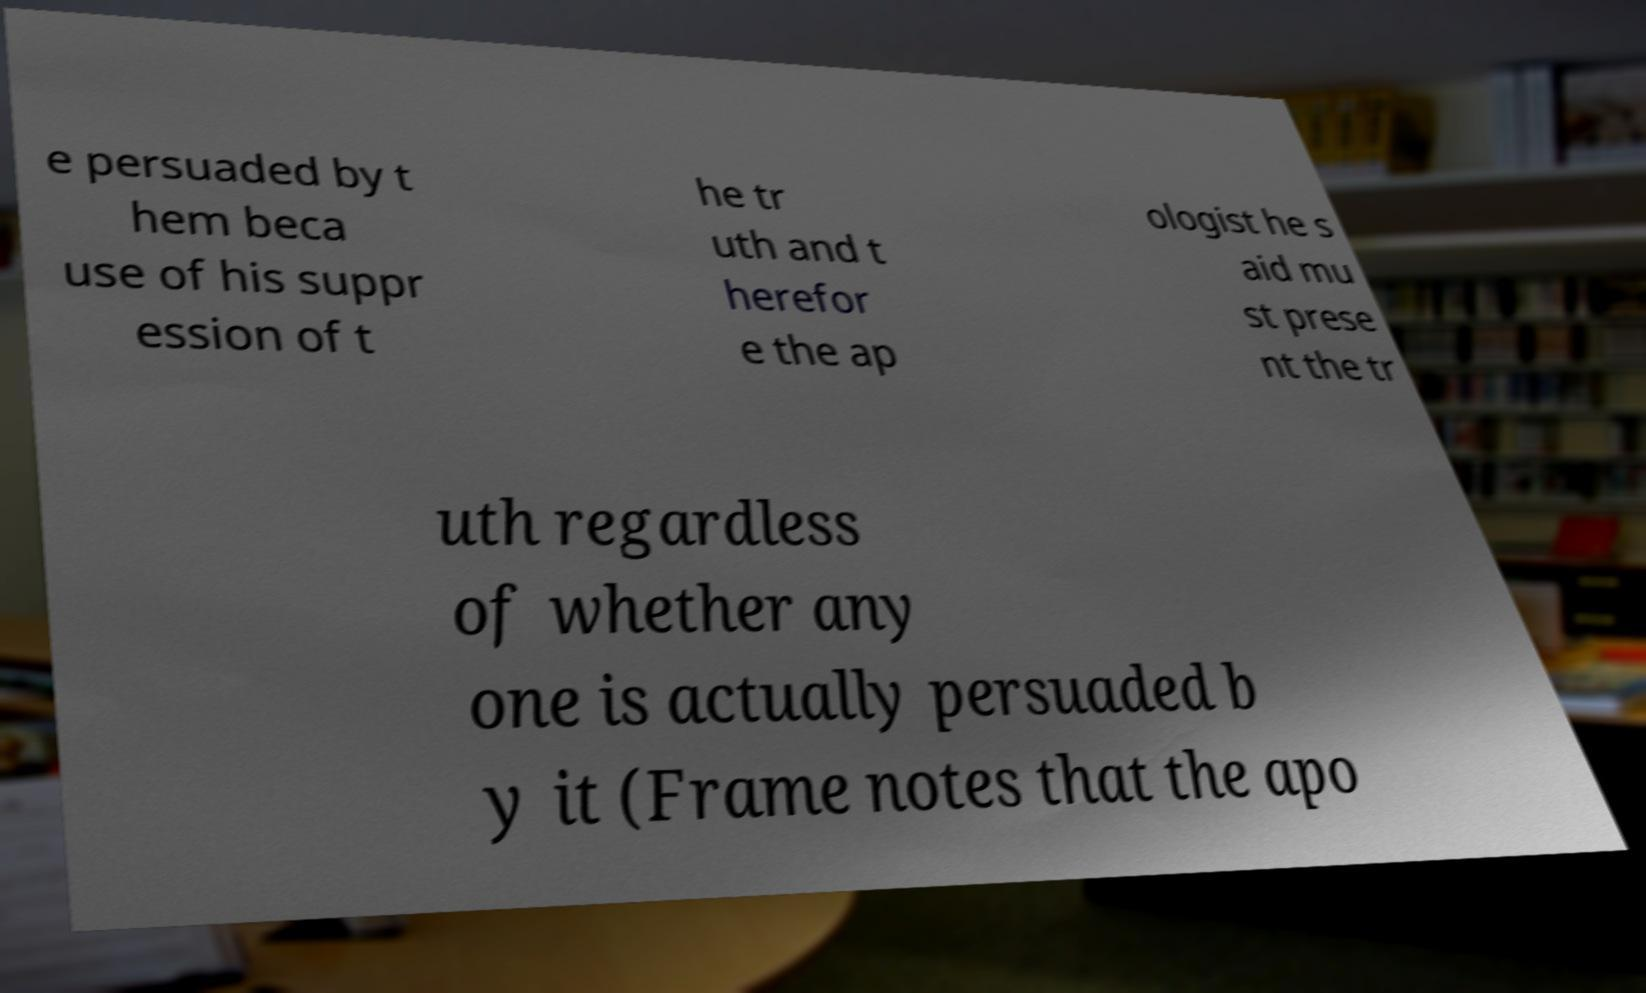Please read and relay the text visible in this image. What does it say? e persuaded by t hem beca use of his suppr ession of t he tr uth and t herefor e the ap ologist he s aid mu st prese nt the tr uth regardless of whether any one is actually persuaded b y it (Frame notes that the apo 